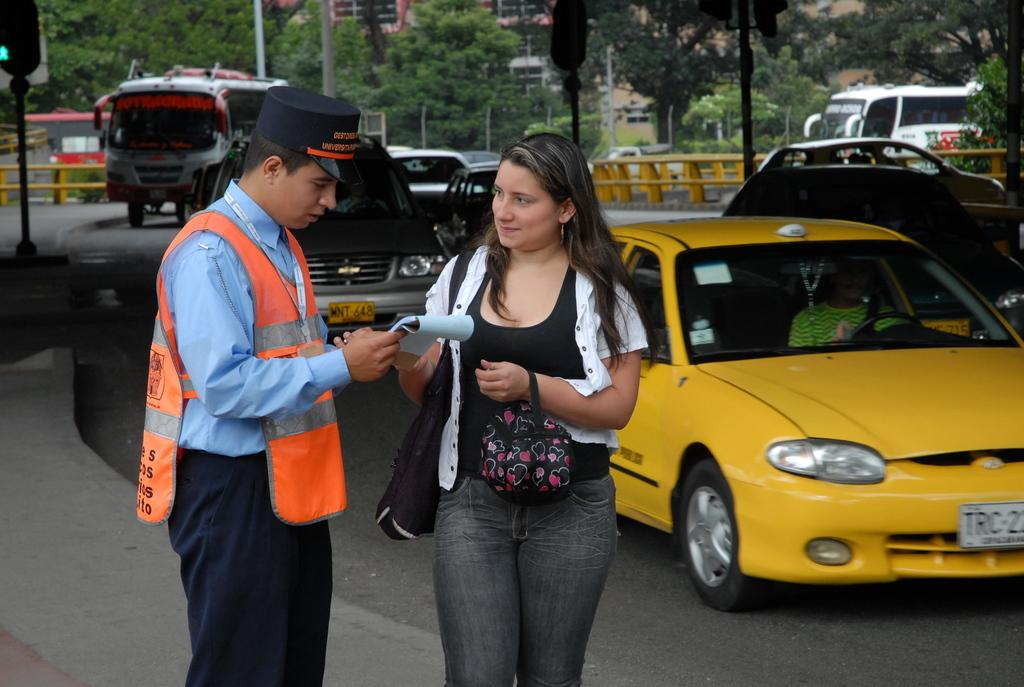Provide a one-sentence caption for the provided image. a license plate that has TRC on the plate. 